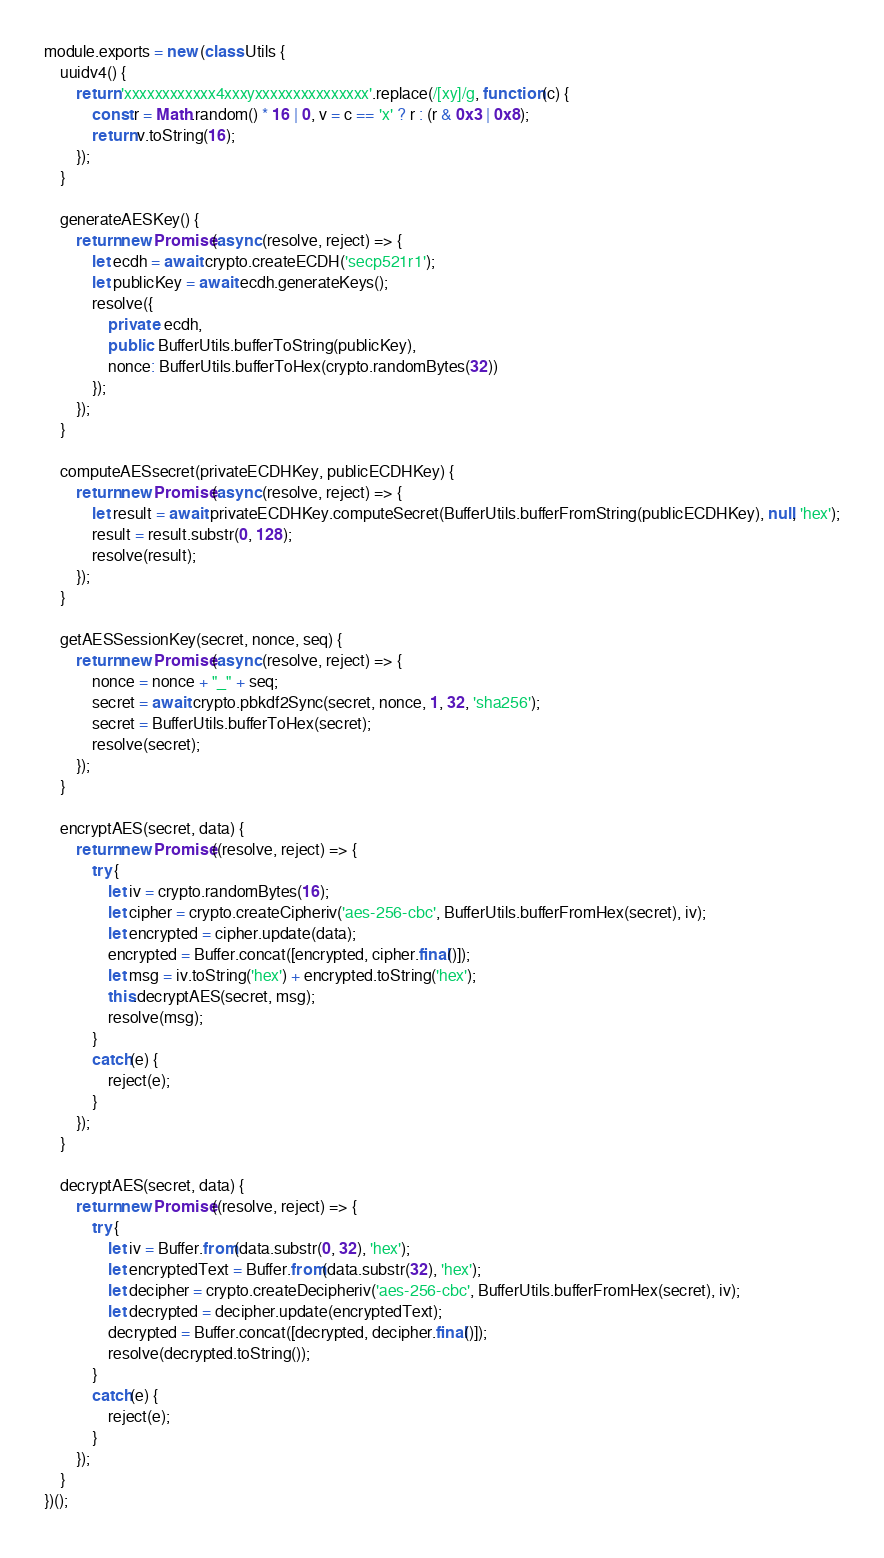<code> <loc_0><loc_0><loc_500><loc_500><_JavaScript_>module.exports = new (class Utils {
    uuidv4() {
        return 'xxxxxxxxxxxx4xxxyxxxxxxxxxxxxxxx'.replace(/[xy]/g, function (c) {
            const r = Math.random() * 16 | 0, v = c == 'x' ? r : (r & 0x3 | 0x8);
            return v.toString(16);
        });
    }

    generateAESKey() {
        return new Promise(async (resolve, reject) => {
            let ecdh = await crypto.createECDH('secp521r1');
            let publicKey = await ecdh.generateKeys();
            resolve({
                private: ecdh,
                public: BufferUtils.bufferToString(publicKey),
                nonce: BufferUtils.bufferToHex(crypto.randomBytes(32))
            });
        });
    }

    computeAESsecret(privateECDHKey, publicECDHKey) {
        return new Promise(async (resolve, reject) => {
            let result = await privateECDHKey.computeSecret(BufferUtils.bufferFromString(publicECDHKey), null, 'hex');
            result = result.substr(0, 128);
            resolve(result);
        });
    }

    getAESSessionKey(secret, nonce, seq) {
        return new Promise(async (resolve, reject) => {
            nonce = nonce + "_" + seq;
            secret = await crypto.pbkdf2Sync(secret, nonce, 1, 32, 'sha256');
            secret = BufferUtils.bufferToHex(secret);
            resolve(secret);
        });
    }

    encryptAES(secret, data) {
        return new Promise((resolve, reject) => {
            try {
                let iv = crypto.randomBytes(16);
                let cipher = crypto.createCipheriv('aes-256-cbc', BufferUtils.bufferFromHex(secret), iv);
                let encrypted = cipher.update(data);
                encrypted = Buffer.concat([encrypted, cipher.final()]);
                let msg = iv.toString('hex') + encrypted.toString('hex');
                this.decryptAES(secret, msg);
                resolve(msg);
            }
            catch(e) {
                reject(e);
            }
        });
    }

    decryptAES(secret, data) {
        return new Promise((resolve, reject) => {
            try {
                let iv = Buffer.from(data.substr(0, 32), 'hex');
                let encryptedText = Buffer.from(data.substr(32), 'hex');
                let decipher = crypto.createDecipheriv('aes-256-cbc', BufferUtils.bufferFromHex(secret), iv);
                let decrypted = decipher.update(encryptedText);
                decrypted = Buffer.concat([decrypted, decipher.final()]);
                resolve(decrypted.toString());
            }
            catch(e) {
                reject(e);
            }
        });
    }
})();</code> 